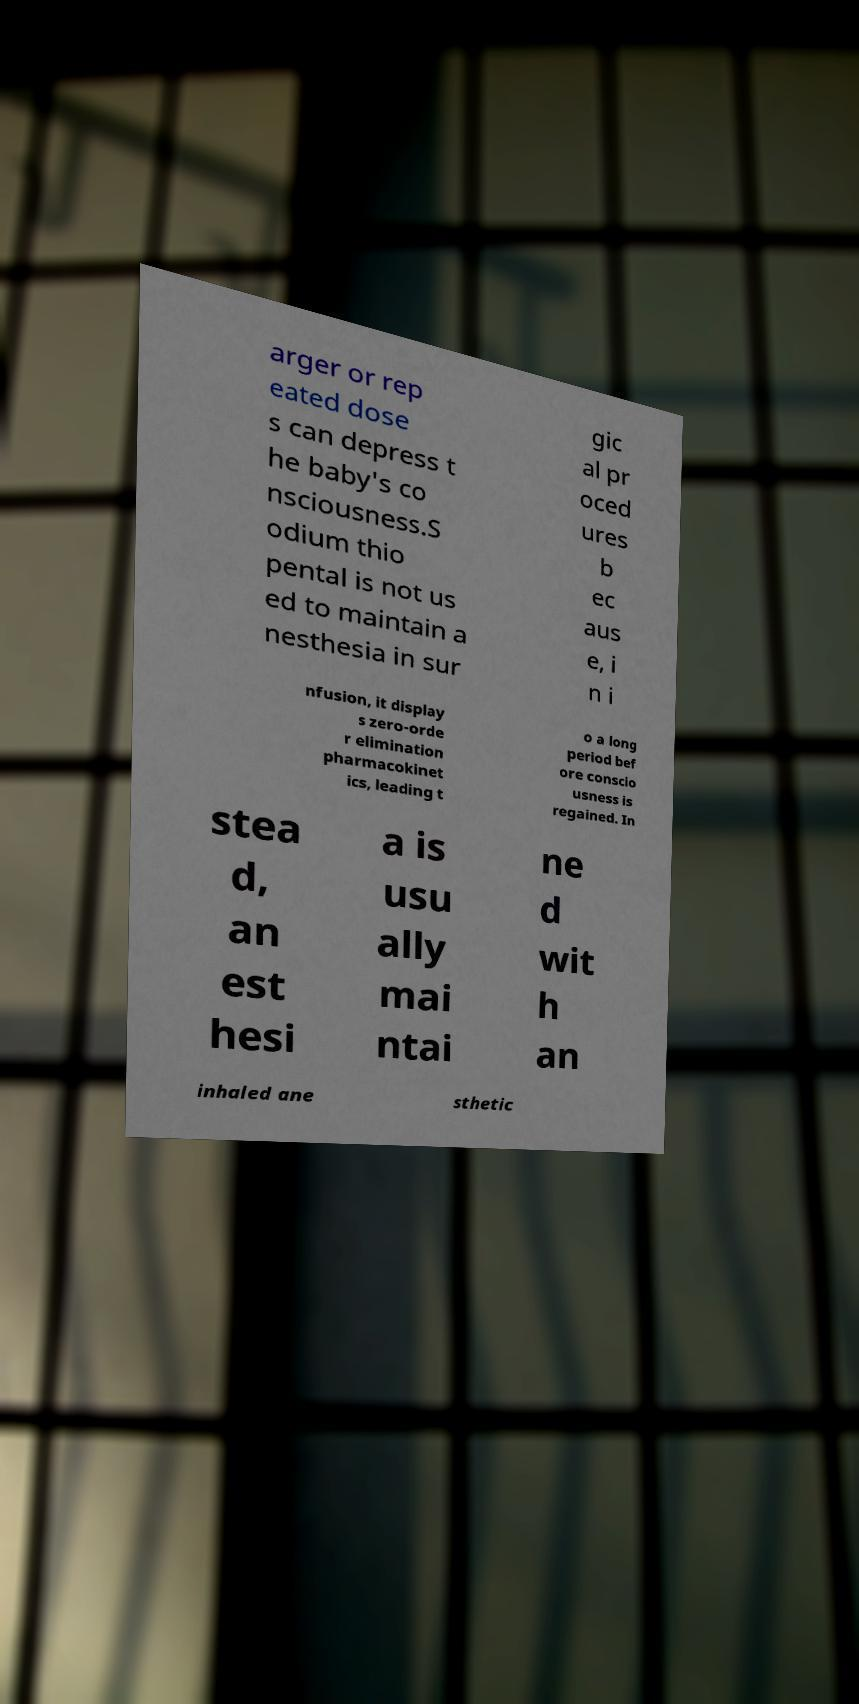What messages or text are displayed in this image? I need them in a readable, typed format. arger or rep eated dose s can depress t he baby's co nsciousness.S odium thio pental is not us ed to maintain a nesthesia in sur gic al pr oced ures b ec aus e, i n i nfusion, it display s zero-orde r elimination pharmacokinet ics, leading t o a long period bef ore conscio usness is regained. In stea d, an est hesi a is usu ally mai ntai ne d wit h an inhaled ane sthetic 